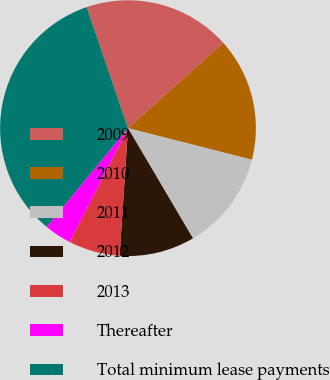<chart> <loc_0><loc_0><loc_500><loc_500><pie_chart><fcel>2009<fcel>2010<fcel>2011<fcel>2012<fcel>2013<fcel>Thereafter<fcel>Total minimum lease payments<nl><fcel>18.62%<fcel>15.59%<fcel>12.55%<fcel>9.52%<fcel>6.48%<fcel>3.45%<fcel>33.79%<nl></chart> 